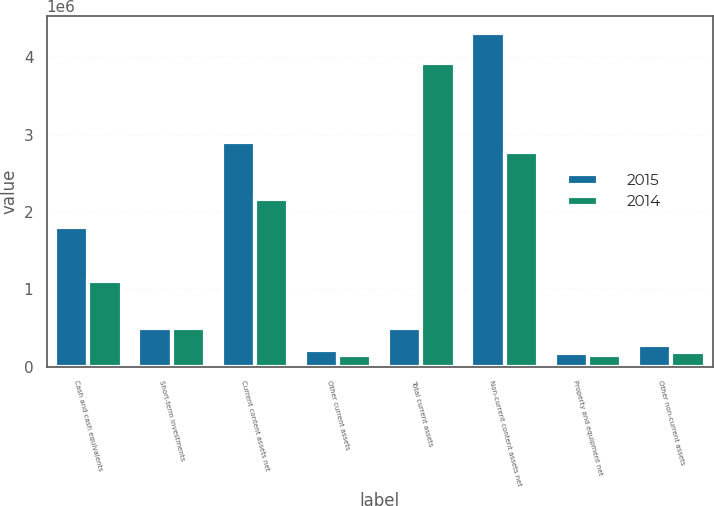<chart> <loc_0><loc_0><loc_500><loc_500><stacked_bar_chart><ecel><fcel>Cash and cash equivalents<fcel>Short-term investments<fcel>Current content assets net<fcel>Other current assets<fcel>Total current assets<fcel>Non-current content assets net<fcel>Property and equipment net<fcel>Other non-current assets<nl><fcel>2015<fcel>1.80933e+06<fcel>501385<fcel>2.906e+06<fcel>215127<fcel>501385<fcel>4.31282e+06<fcel>173412<fcel>284802<nl><fcel>2014<fcel>1.11361e+06<fcel>494888<fcel>2.16613e+06<fcel>152423<fcel>3.92705e+06<fcel>2.77333e+06<fcel>149875<fcel>192246<nl></chart> 